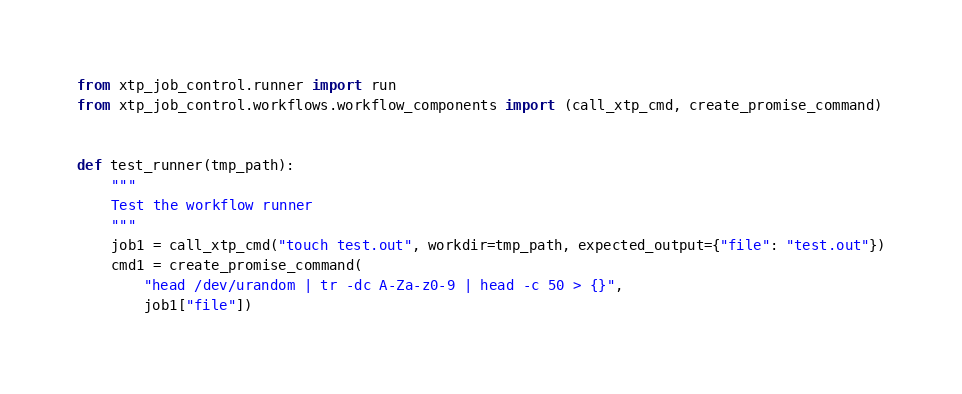Convert code to text. <code><loc_0><loc_0><loc_500><loc_500><_Python_>from xtp_job_control.runner import run
from xtp_job_control.workflows.workflow_components import (call_xtp_cmd, create_promise_command)


def test_runner(tmp_path):
    """
    Test the workflow runner
    """
    job1 = call_xtp_cmd("touch test.out", workdir=tmp_path, expected_output={"file": "test.out"})
    cmd1 = create_promise_command(
        "head /dev/urandom | tr -dc A-Za-z0-9 | head -c 50 > {}",
        job1["file"])</code> 